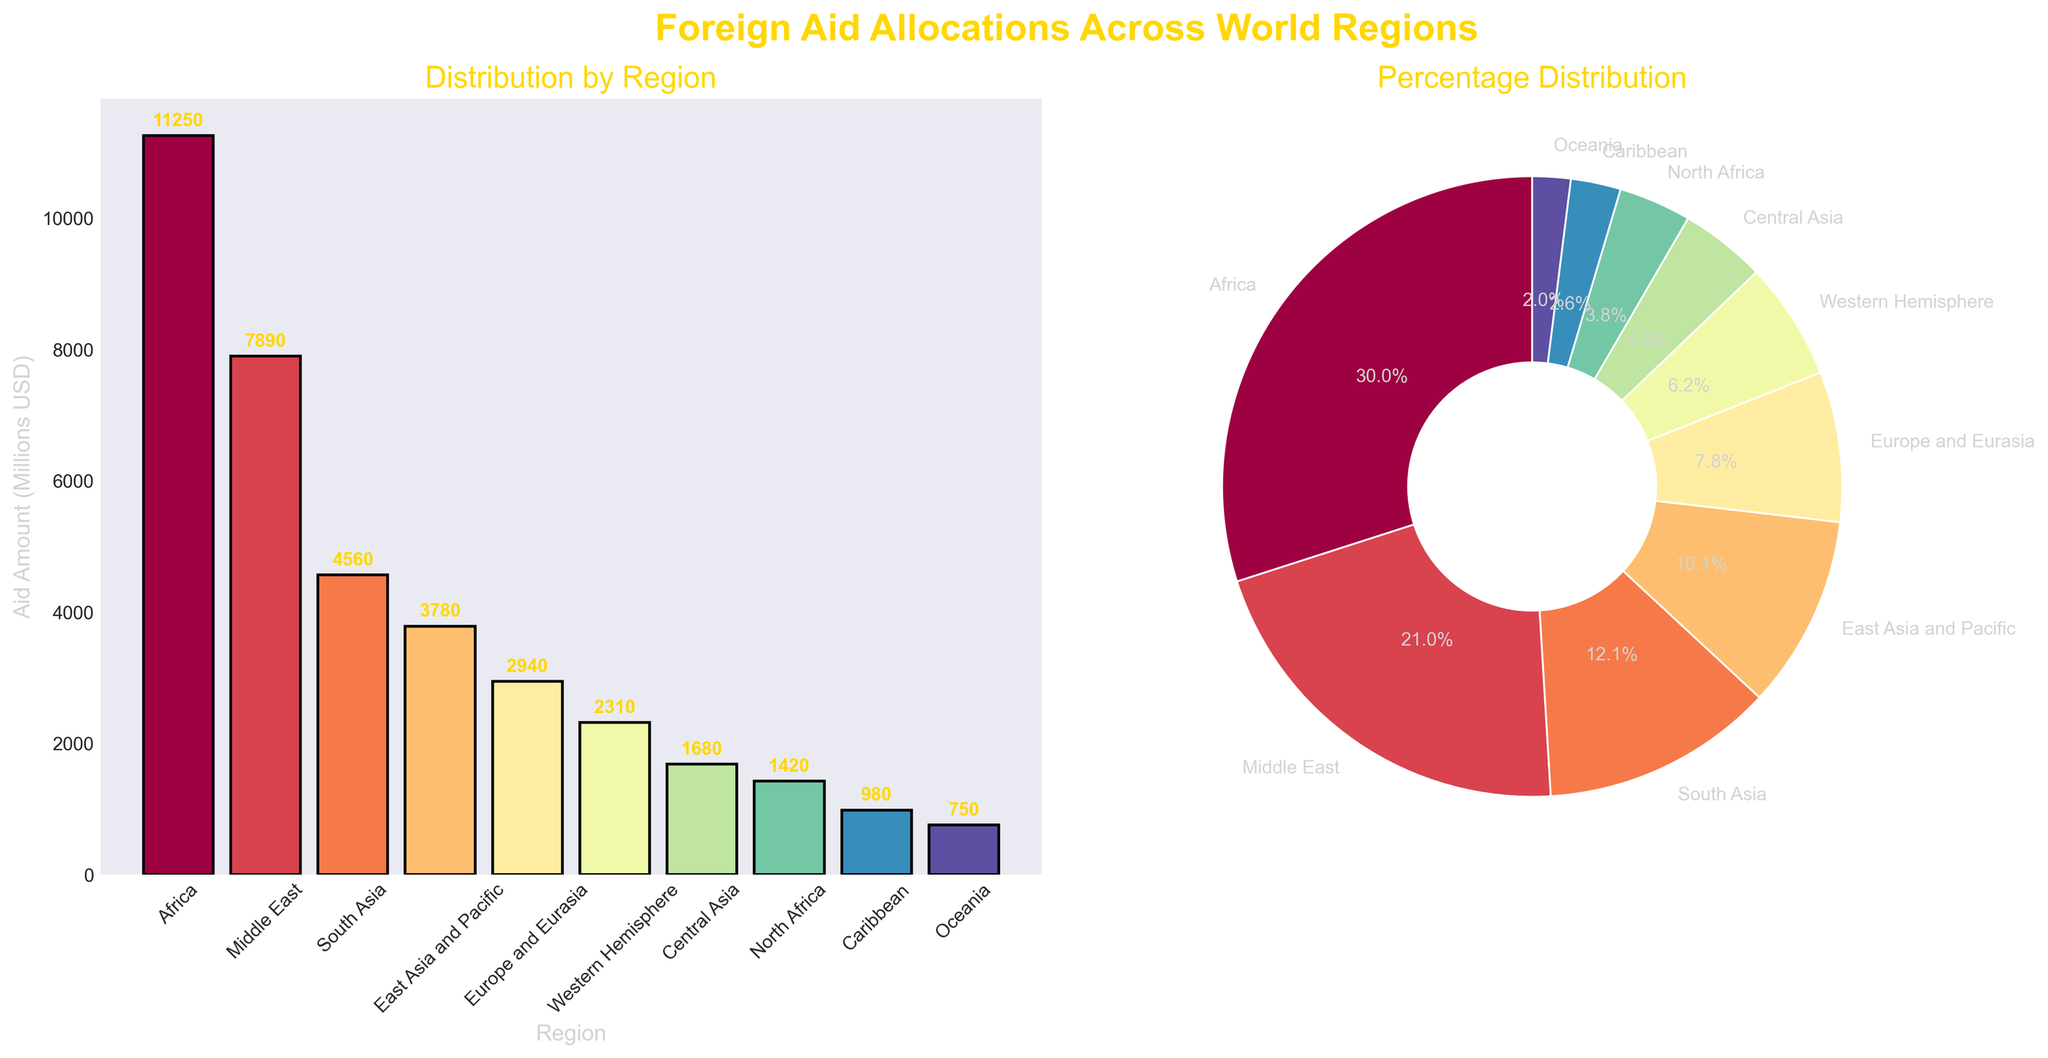what is the region with the second highest aid allocation? From the bar plot, the region with the highest aid allocation is Africa. The second highest bar, which is also visually shorter than Africa's, represents the Middle East. This is also confirmed by the heights and the provided labels on the pie chart.
Answer: Middle East Which region received almost half of the aid allocated to Africa? From the bar plot, Africa received 11250 million USD. By examining the bars, East Asia and Pacific received around 3780 million USD. Dividing 11250 by 2 gives us 5625, and 3780 is close to half of 11250. Thus, East Asia and Pacific received almost half of the aid allocated to Africa.
Answer: East Asia and Pacific What is the total aid allocation to the regions in the Eastern Hemisphere? Countries in the Eastern Hemisphere include Africa, Middle East, South Asia, East Asia, and Pacific, Central Asia, and Europe and Eurasia. Summing the aid amounts from these regions: 11250 + 7890 + 4560 + 3780 + 1420 + 2940 + 1680 = 33520
Answer: 33520 million USD Which region has the smallest allocation, and what percentage of the total aid does it receive? From the bar plot, the smallest bar represents Oceania with 750 million USD. From the pie chart, each slice represents the percentage distribution. The percentage is also denoted on the chart as 1.9%.
Answer: Oceania; 1.9% How does the aid allocation to the Middle East compare to that for Africa and South Asia combined? From the bar plot, Middle East received 7890 million USD, Africa 11250 million USD, and South Asia 4560 million USD. Summing Africa and South Asia's allocations: 11250 + 4560 = 15810 million USD. The Middle East's aid is less than the combined aid for Africa and South Asia.
Answer: Less than the combined aid for Africa and South Asia What is the difference in aid allocation between the Western Hemisphere and Europe and Eurasia? From the bar plot, Western Hemisphere has 2310 million USD and Europe and Eurasia has 2940 million USD. Subtracting Western Hemisphere from Europe and Eurasia: 2940 - 2310 = 630 million USD.
Answer: 630 million USD Which regions constitute approximately 20% of the total aid allocation? From the pie chart, South Asia accounts for 8.2%, and East Asia and Pacific accounts for 6.8%, and thus collectively they contribute 15.0%. Adding another region like Western Hemisphere with 4.2% approximates to 20%.
Answer: South Asia, East Asia and Pacific, Western Hemisphere 